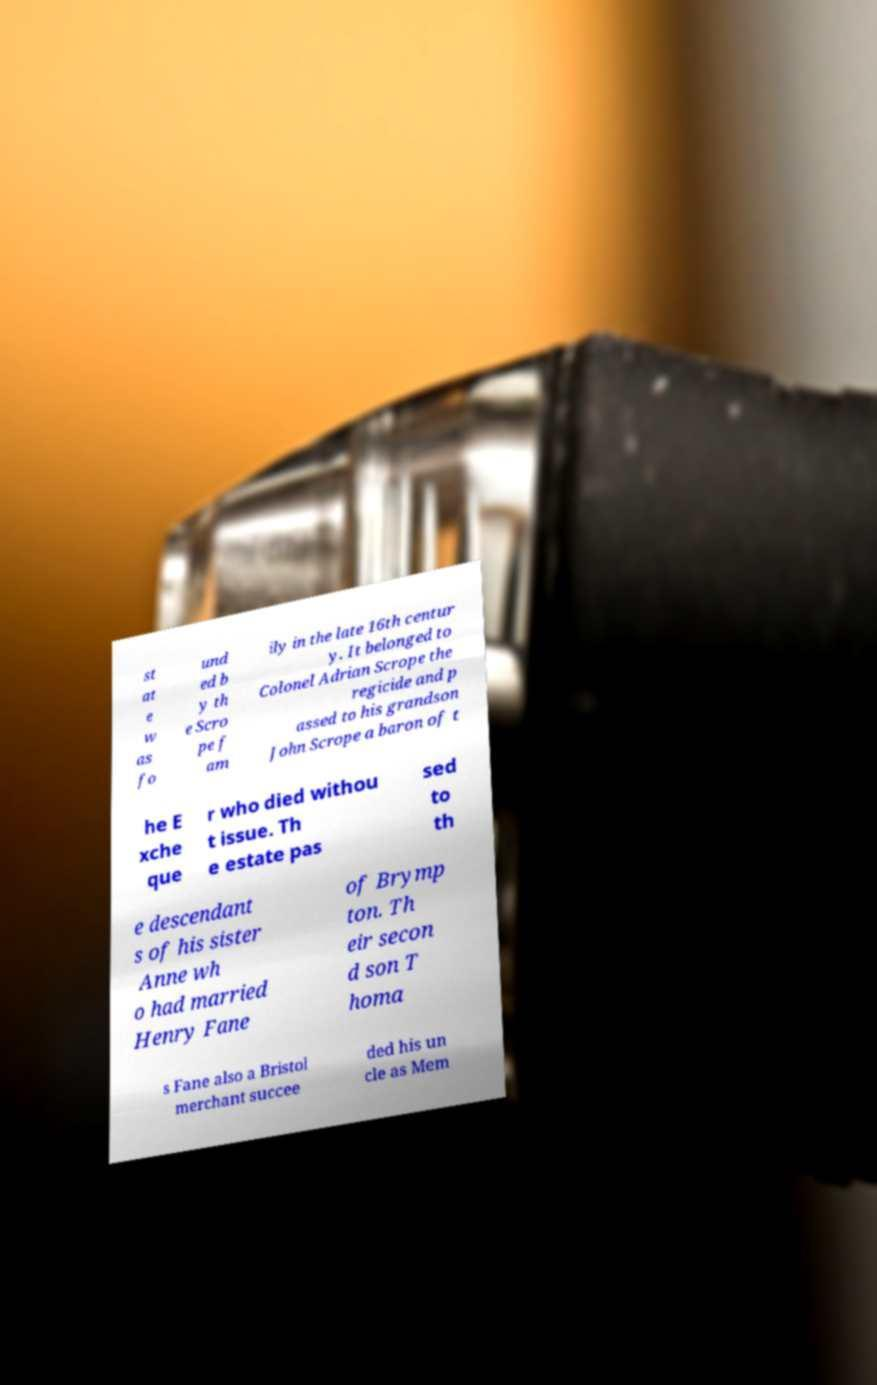Can you read and provide the text displayed in the image?This photo seems to have some interesting text. Can you extract and type it out for me? st at e w as fo und ed b y th e Scro pe f am ily in the late 16th centur y. It belonged to Colonel Adrian Scrope the regicide and p assed to his grandson John Scrope a baron of t he E xche que r who died withou t issue. Th e estate pas sed to th e descendant s of his sister Anne wh o had married Henry Fane of Brymp ton. Th eir secon d son T homa s Fane also a Bristol merchant succee ded his un cle as Mem 